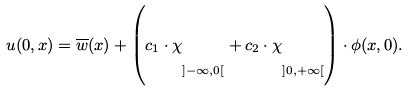<formula> <loc_0><loc_0><loc_500><loc_500>u ( 0 , x ) = \overline { w } ( x ) + \left ( c _ { 1 } \cdot \chi _ { \strut ] - \infty , 0 [ } + c _ { 2 } \cdot \chi _ { \strut ] 0 , + \infty [ } \right ) \cdot \phi ( x , 0 ) .</formula> 